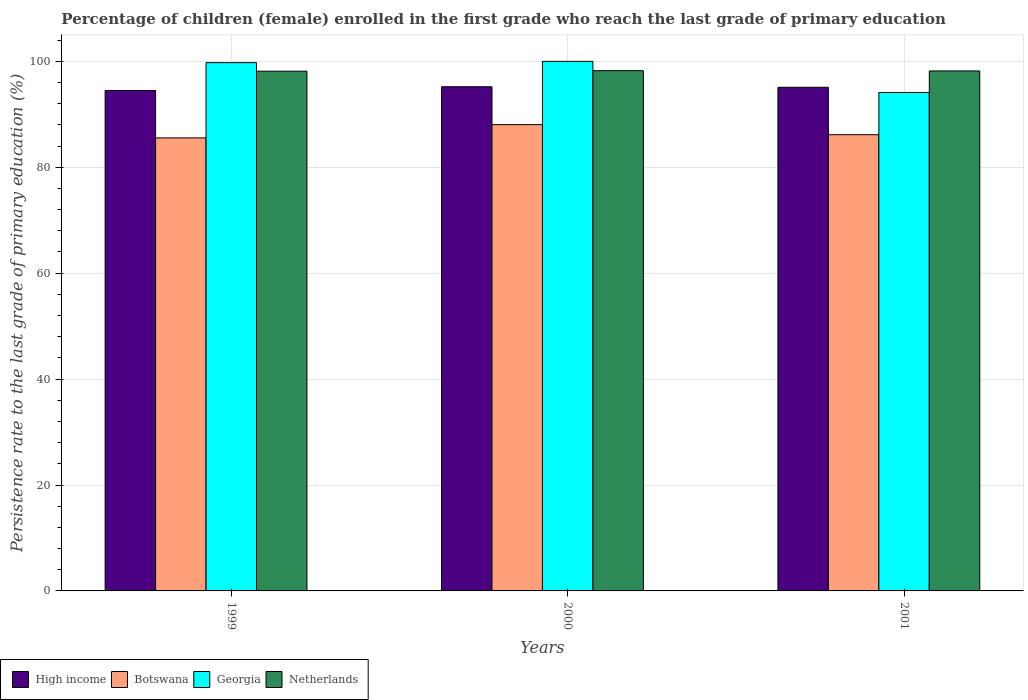How many different coloured bars are there?
Keep it short and to the point. 4. What is the label of the 2nd group of bars from the left?
Offer a very short reply. 2000. In how many cases, is the number of bars for a given year not equal to the number of legend labels?
Provide a succinct answer. 0. What is the persistence rate of children in High income in 2000?
Keep it short and to the point. 95.2. Across all years, what is the maximum persistence rate of children in Netherlands?
Your answer should be compact. 98.24. Across all years, what is the minimum persistence rate of children in Netherlands?
Provide a succinct answer. 98.14. What is the total persistence rate of children in Georgia in the graph?
Make the answer very short. 293.88. What is the difference between the persistence rate of children in Netherlands in 2000 and that in 2001?
Give a very brief answer. 0.05. What is the difference between the persistence rate of children in Georgia in 2000 and the persistence rate of children in Botswana in 2001?
Make the answer very short. 13.85. What is the average persistence rate of children in Botswana per year?
Ensure brevity in your answer.  86.58. In the year 2001, what is the difference between the persistence rate of children in Botswana and persistence rate of children in Georgia?
Offer a very short reply. -7.98. In how many years, is the persistence rate of children in Botswana greater than 92 %?
Your response must be concise. 0. What is the ratio of the persistence rate of children in Botswana in 1999 to that in 2000?
Your answer should be compact. 0.97. What is the difference between the highest and the second highest persistence rate of children in Botswana?
Give a very brief answer. 1.9. What is the difference between the highest and the lowest persistence rate of children in Botswana?
Provide a succinct answer. 2.51. Is the sum of the persistence rate of children in High income in 1999 and 2000 greater than the maximum persistence rate of children in Netherlands across all years?
Offer a very short reply. Yes. Is it the case that in every year, the sum of the persistence rate of children in High income and persistence rate of children in Georgia is greater than the sum of persistence rate of children in Botswana and persistence rate of children in Netherlands?
Offer a very short reply. No. What is the difference between two consecutive major ticks on the Y-axis?
Your answer should be very brief. 20. Are the values on the major ticks of Y-axis written in scientific E-notation?
Give a very brief answer. No. Does the graph contain grids?
Your answer should be compact. Yes. What is the title of the graph?
Your answer should be compact. Percentage of children (female) enrolled in the first grade who reach the last grade of primary education. What is the label or title of the X-axis?
Give a very brief answer. Years. What is the label or title of the Y-axis?
Provide a succinct answer. Persistence rate to the last grade of primary education (%). What is the Persistence rate to the last grade of primary education (%) in High income in 1999?
Make the answer very short. 94.5. What is the Persistence rate to the last grade of primary education (%) of Botswana in 1999?
Offer a terse response. 85.55. What is the Persistence rate to the last grade of primary education (%) in Georgia in 1999?
Keep it short and to the point. 99.75. What is the Persistence rate to the last grade of primary education (%) in Netherlands in 1999?
Provide a succinct answer. 98.14. What is the Persistence rate to the last grade of primary education (%) of High income in 2000?
Offer a terse response. 95.2. What is the Persistence rate to the last grade of primary education (%) of Botswana in 2000?
Your response must be concise. 88.05. What is the Persistence rate to the last grade of primary education (%) in Georgia in 2000?
Make the answer very short. 100. What is the Persistence rate to the last grade of primary education (%) in Netherlands in 2000?
Provide a short and direct response. 98.24. What is the Persistence rate to the last grade of primary education (%) of High income in 2001?
Give a very brief answer. 95.1. What is the Persistence rate to the last grade of primary education (%) in Botswana in 2001?
Provide a short and direct response. 86.15. What is the Persistence rate to the last grade of primary education (%) of Georgia in 2001?
Offer a very short reply. 94.13. What is the Persistence rate to the last grade of primary education (%) of Netherlands in 2001?
Offer a very short reply. 98.19. Across all years, what is the maximum Persistence rate to the last grade of primary education (%) of High income?
Provide a short and direct response. 95.2. Across all years, what is the maximum Persistence rate to the last grade of primary education (%) of Botswana?
Make the answer very short. 88.05. Across all years, what is the maximum Persistence rate to the last grade of primary education (%) of Netherlands?
Provide a short and direct response. 98.24. Across all years, what is the minimum Persistence rate to the last grade of primary education (%) of High income?
Ensure brevity in your answer.  94.5. Across all years, what is the minimum Persistence rate to the last grade of primary education (%) in Botswana?
Offer a very short reply. 85.55. Across all years, what is the minimum Persistence rate to the last grade of primary education (%) of Georgia?
Offer a very short reply. 94.13. Across all years, what is the minimum Persistence rate to the last grade of primary education (%) of Netherlands?
Provide a succinct answer. 98.14. What is the total Persistence rate to the last grade of primary education (%) of High income in the graph?
Ensure brevity in your answer.  284.81. What is the total Persistence rate to the last grade of primary education (%) of Botswana in the graph?
Give a very brief answer. 259.75. What is the total Persistence rate to the last grade of primary education (%) in Georgia in the graph?
Keep it short and to the point. 293.88. What is the total Persistence rate to the last grade of primary education (%) in Netherlands in the graph?
Keep it short and to the point. 294.57. What is the difference between the Persistence rate to the last grade of primary education (%) of High income in 1999 and that in 2000?
Provide a short and direct response. -0.7. What is the difference between the Persistence rate to the last grade of primary education (%) of Botswana in 1999 and that in 2000?
Give a very brief answer. -2.51. What is the difference between the Persistence rate to the last grade of primary education (%) of Georgia in 1999 and that in 2000?
Keep it short and to the point. -0.25. What is the difference between the Persistence rate to the last grade of primary education (%) of Netherlands in 1999 and that in 2000?
Your answer should be very brief. -0.09. What is the difference between the Persistence rate to the last grade of primary education (%) of High income in 1999 and that in 2001?
Offer a terse response. -0.6. What is the difference between the Persistence rate to the last grade of primary education (%) of Botswana in 1999 and that in 2001?
Provide a short and direct response. -0.61. What is the difference between the Persistence rate to the last grade of primary education (%) of Georgia in 1999 and that in 2001?
Provide a short and direct response. 5.63. What is the difference between the Persistence rate to the last grade of primary education (%) in Netherlands in 1999 and that in 2001?
Provide a short and direct response. -0.04. What is the difference between the Persistence rate to the last grade of primary education (%) in High income in 2000 and that in 2001?
Provide a succinct answer. 0.1. What is the difference between the Persistence rate to the last grade of primary education (%) of Botswana in 2000 and that in 2001?
Your answer should be very brief. 1.9. What is the difference between the Persistence rate to the last grade of primary education (%) in Georgia in 2000 and that in 2001?
Offer a terse response. 5.87. What is the difference between the Persistence rate to the last grade of primary education (%) in Netherlands in 2000 and that in 2001?
Your answer should be compact. 0.05. What is the difference between the Persistence rate to the last grade of primary education (%) of High income in 1999 and the Persistence rate to the last grade of primary education (%) of Botswana in 2000?
Ensure brevity in your answer.  6.45. What is the difference between the Persistence rate to the last grade of primary education (%) of High income in 1999 and the Persistence rate to the last grade of primary education (%) of Georgia in 2000?
Offer a very short reply. -5.5. What is the difference between the Persistence rate to the last grade of primary education (%) of High income in 1999 and the Persistence rate to the last grade of primary education (%) of Netherlands in 2000?
Provide a short and direct response. -3.74. What is the difference between the Persistence rate to the last grade of primary education (%) of Botswana in 1999 and the Persistence rate to the last grade of primary education (%) of Georgia in 2000?
Your response must be concise. -14.45. What is the difference between the Persistence rate to the last grade of primary education (%) of Botswana in 1999 and the Persistence rate to the last grade of primary education (%) of Netherlands in 2000?
Give a very brief answer. -12.69. What is the difference between the Persistence rate to the last grade of primary education (%) of Georgia in 1999 and the Persistence rate to the last grade of primary education (%) of Netherlands in 2000?
Offer a terse response. 1.52. What is the difference between the Persistence rate to the last grade of primary education (%) in High income in 1999 and the Persistence rate to the last grade of primary education (%) in Botswana in 2001?
Make the answer very short. 8.35. What is the difference between the Persistence rate to the last grade of primary education (%) in High income in 1999 and the Persistence rate to the last grade of primary education (%) in Georgia in 2001?
Make the answer very short. 0.37. What is the difference between the Persistence rate to the last grade of primary education (%) of High income in 1999 and the Persistence rate to the last grade of primary education (%) of Netherlands in 2001?
Your response must be concise. -3.69. What is the difference between the Persistence rate to the last grade of primary education (%) in Botswana in 1999 and the Persistence rate to the last grade of primary education (%) in Georgia in 2001?
Provide a short and direct response. -8.58. What is the difference between the Persistence rate to the last grade of primary education (%) of Botswana in 1999 and the Persistence rate to the last grade of primary education (%) of Netherlands in 2001?
Your answer should be compact. -12.64. What is the difference between the Persistence rate to the last grade of primary education (%) in Georgia in 1999 and the Persistence rate to the last grade of primary education (%) in Netherlands in 2001?
Your response must be concise. 1.57. What is the difference between the Persistence rate to the last grade of primary education (%) of High income in 2000 and the Persistence rate to the last grade of primary education (%) of Botswana in 2001?
Your answer should be very brief. 9.05. What is the difference between the Persistence rate to the last grade of primary education (%) of High income in 2000 and the Persistence rate to the last grade of primary education (%) of Georgia in 2001?
Ensure brevity in your answer.  1.07. What is the difference between the Persistence rate to the last grade of primary education (%) in High income in 2000 and the Persistence rate to the last grade of primary education (%) in Netherlands in 2001?
Provide a succinct answer. -2.99. What is the difference between the Persistence rate to the last grade of primary education (%) of Botswana in 2000 and the Persistence rate to the last grade of primary education (%) of Georgia in 2001?
Your response must be concise. -6.07. What is the difference between the Persistence rate to the last grade of primary education (%) of Botswana in 2000 and the Persistence rate to the last grade of primary education (%) of Netherlands in 2001?
Your answer should be very brief. -10.14. What is the difference between the Persistence rate to the last grade of primary education (%) of Georgia in 2000 and the Persistence rate to the last grade of primary education (%) of Netherlands in 2001?
Offer a terse response. 1.81. What is the average Persistence rate to the last grade of primary education (%) in High income per year?
Make the answer very short. 94.94. What is the average Persistence rate to the last grade of primary education (%) in Botswana per year?
Provide a short and direct response. 86.58. What is the average Persistence rate to the last grade of primary education (%) in Georgia per year?
Your answer should be very brief. 97.96. What is the average Persistence rate to the last grade of primary education (%) of Netherlands per year?
Give a very brief answer. 98.19. In the year 1999, what is the difference between the Persistence rate to the last grade of primary education (%) of High income and Persistence rate to the last grade of primary education (%) of Botswana?
Offer a very short reply. 8.95. In the year 1999, what is the difference between the Persistence rate to the last grade of primary education (%) in High income and Persistence rate to the last grade of primary education (%) in Georgia?
Offer a terse response. -5.25. In the year 1999, what is the difference between the Persistence rate to the last grade of primary education (%) of High income and Persistence rate to the last grade of primary education (%) of Netherlands?
Give a very brief answer. -3.64. In the year 1999, what is the difference between the Persistence rate to the last grade of primary education (%) in Botswana and Persistence rate to the last grade of primary education (%) in Georgia?
Your answer should be very brief. -14.21. In the year 1999, what is the difference between the Persistence rate to the last grade of primary education (%) in Botswana and Persistence rate to the last grade of primary education (%) in Netherlands?
Ensure brevity in your answer.  -12.6. In the year 1999, what is the difference between the Persistence rate to the last grade of primary education (%) of Georgia and Persistence rate to the last grade of primary education (%) of Netherlands?
Keep it short and to the point. 1.61. In the year 2000, what is the difference between the Persistence rate to the last grade of primary education (%) of High income and Persistence rate to the last grade of primary education (%) of Botswana?
Keep it short and to the point. 7.15. In the year 2000, what is the difference between the Persistence rate to the last grade of primary education (%) in High income and Persistence rate to the last grade of primary education (%) in Georgia?
Your answer should be very brief. -4.8. In the year 2000, what is the difference between the Persistence rate to the last grade of primary education (%) in High income and Persistence rate to the last grade of primary education (%) in Netherlands?
Give a very brief answer. -3.04. In the year 2000, what is the difference between the Persistence rate to the last grade of primary education (%) of Botswana and Persistence rate to the last grade of primary education (%) of Georgia?
Your answer should be compact. -11.95. In the year 2000, what is the difference between the Persistence rate to the last grade of primary education (%) in Botswana and Persistence rate to the last grade of primary education (%) in Netherlands?
Your answer should be compact. -10.19. In the year 2000, what is the difference between the Persistence rate to the last grade of primary education (%) in Georgia and Persistence rate to the last grade of primary education (%) in Netherlands?
Your response must be concise. 1.76. In the year 2001, what is the difference between the Persistence rate to the last grade of primary education (%) in High income and Persistence rate to the last grade of primary education (%) in Botswana?
Offer a very short reply. 8.95. In the year 2001, what is the difference between the Persistence rate to the last grade of primary education (%) of High income and Persistence rate to the last grade of primary education (%) of Georgia?
Provide a short and direct response. 0.98. In the year 2001, what is the difference between the Persistence rate to the last grade of primary education (%) in High income and Persistence rate to the last grade of primary education (%) in Netherlands?
Provide a succinct answer. -3.08. In the year 2001, what is the difference between the Persistence rate to the last grade of primary education (%) in Botswana and Persistence rate to the last grade of primary education (%) in Georgia?
Make the answer very short. -7.98. In the year 2001, what is the difference between the Persistence rate to the last grade of primary education (%) of Botswana and Persistence rate to the last grade of primary education (%) of Netherlands?
Offer a very short reply. -12.04. In the year 2001, what is the difference between the Persistence rate to the last grade of primary education (%) in Georgia and Persistence rate to the last grade of primary education (%) in Netherlands?
Give a very brief answer. -4.06. What is the ratio of the Persistence rate to the last grade of primary education (%) of Botswana in 1999 to that in 2000?
Your answer should be very brief. 0.97. What is the ratio of the Persistence rate to the last grade of primary education (%) in Georgia in 1999 to that in 2000?
Your response must be concise. 1. What is the ratio of the Persistence rate to the last grade of primary education (%) of Botswana in 1999 to that in 2001?
Keep it short and to the point. 0.99. What is the ratio of the Persistence rate to the last grade of primary education (%) in Georgia in 1999 to that in 2001?
Provide a succinct answer. 1.06. What is the ratio of the Persistence rate to the last grade of primary education (%) of Netherlands in 1999 to that in 2001?
Offer a very short reply. 1. What is the ratio of the Persistence rate to the last grade of primary education (%) of High income in 2000 to that in 2001?
Offer a very short reply. 1. What is the ratio of the Persistence rate to the last grade of primary education (%) of Botswana in 2000 to that in 2001?
Your answer should be compact. 1.02. What is the ratio of the Persistence rate to the last grade of primary education (%) of Georgia in 2000 to that in 2001?
Your answer should be very brief. 1.06. What is the difference between the highest and the second highest Persistence rate to the last grade of primary education (%) of High income?
Ensure brevity in your answer.  0.1. What is the difference between the highest and the second highest Persistence rate to the last grade of primary education (%) of Botswana?
Make the answer very short. 1.9. What is the difference between the highest and the second highest Persistence rate to the last grade of primary education (%) in Georgia?
Offer a very short reply. 0.25. What is the difference between the highest and the second highest Persistence rate to the last grade of primary education (%) in Netherlands?
Provide a succinct answer. 0.05. What is the difference between the highest and the lowest Persistence rate to the last grade of primary education (%) in High income?
Your answer should be compact. 0.7. What is the difference between the highest and the lowest Persistence rate to the last grade of primary education (%) in Botswana?
Give a very brief answer. 2.51. What is the difference between the highest and the lowest Persistence rate to the last grade of primary education (%) in Georgia?
Give a very brief answer. 5.87. What is the difference between the highest and the lowest Persistence rate to the last grade of primary education (%) in Netherlands?
Provide a succinct answer. 0.09. 